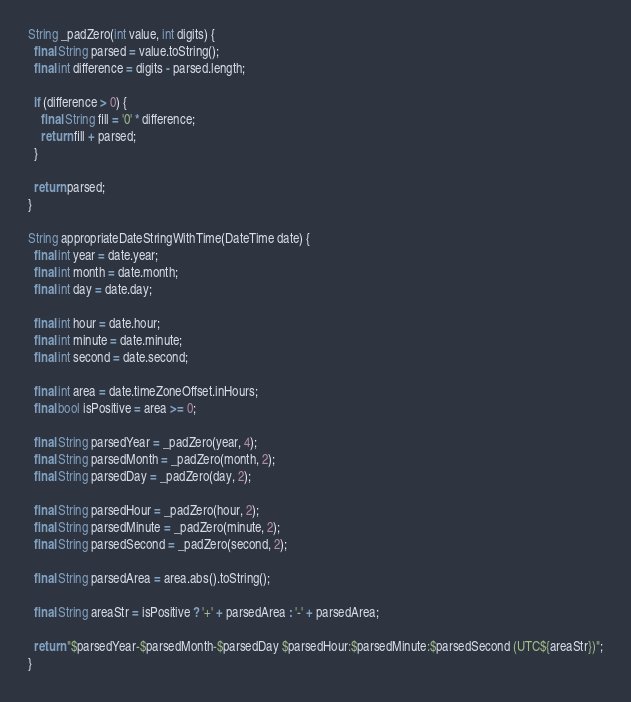Convert code to text. <code><loc_0><loc_0><loc_500><loc_500><_Dart_>String _padZero(int value, int digits) {
  final String parsed = value.toString();
  final int difference = digits - parsed.length;

  if (difference > 0) {
    final String fill = '0' * difference;
    return fill + parsed;
  }

  return parsed;
}

String appropriateDateStringWithTime(DateTime date) {
  final int year = date.year;
  final int month = date.month;
  final int day = date.day;

  final int hour = date.hour;
  final int minute = date.minute;
  final int second = date.second;

  final int area = date.timeZoneOffset.inHours;
  final bool isPositive = area >= 0;

  final String parsedYear = _padZero(year, 4);
  final String parsedMonth = _padZero(month, 2);
  final String parsedDay = _padZero(day, 2);

  final String parsedHour = _padZero(hour, 2);
  final String parsedMinute = _padZero(minute, 2);
  final String parsedSecond = _padZero(second, 2);

  final String parsedArea = area.abs().toString();

  final String areaStr = isPositive ? '+' + parsedArea : '-' + parsedArea;

  return "$parsedYear-$parsedMonth-$parsedDay $parsedHour:$parsedMinute:$parsedSecond (UTC${areaStr})";
}
</code> 